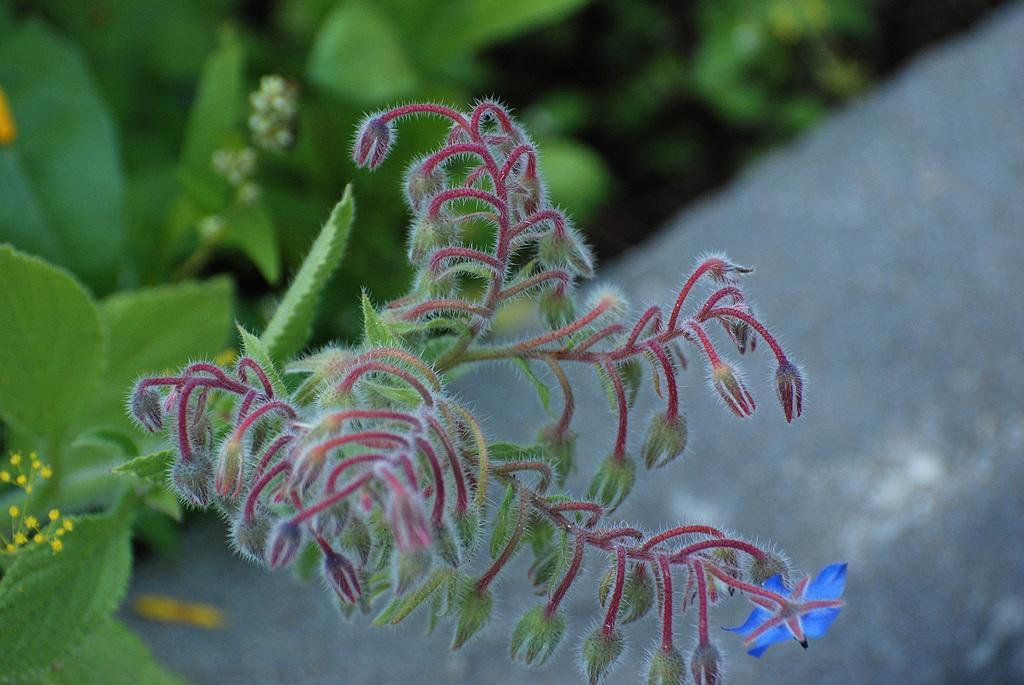Can you describe this image briefly? Here in this picture we can see flowers present on plants. 